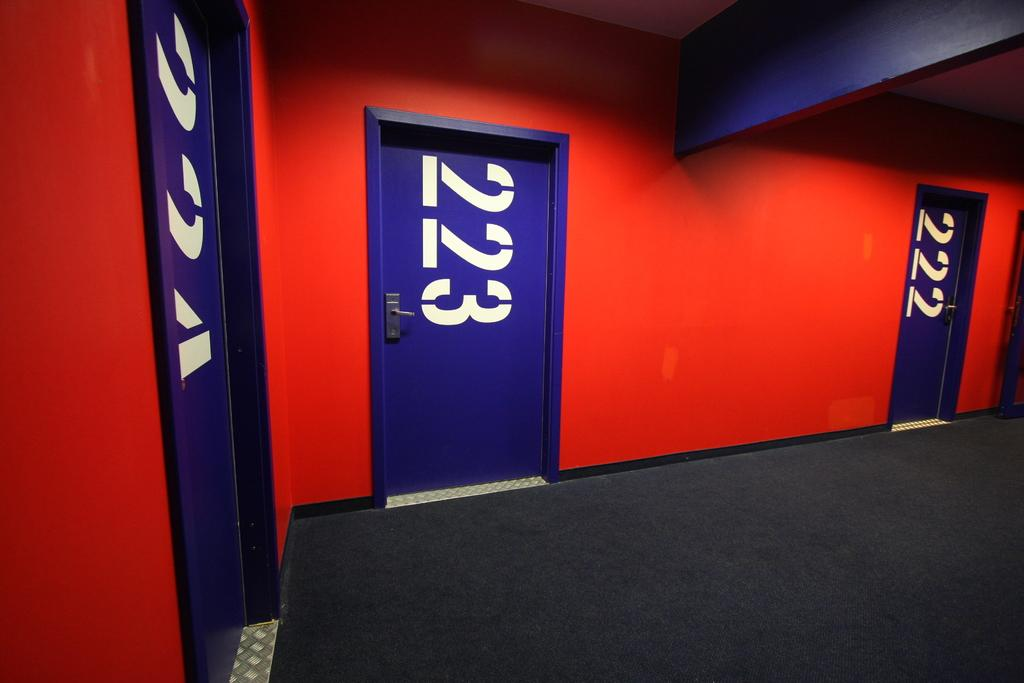How many doors are visible in the image? There are three doors in the image. What is the color of the doors? The doors are blue in color. Are there any markings on the doors? Yes, there are numbers on the doors. What color is the wall behind the doors? There is a red color wall in the image. What type of cover is being used for the volleyball game in the image? There is no volleyball game present in the image, so it is not possible to determine what type of cover might be used. 